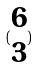<formula> <loc_0><loc_0><loc_500><loc_500>( \begin{matrix} 6 \\ 3 \end{matrix} )</formula> 